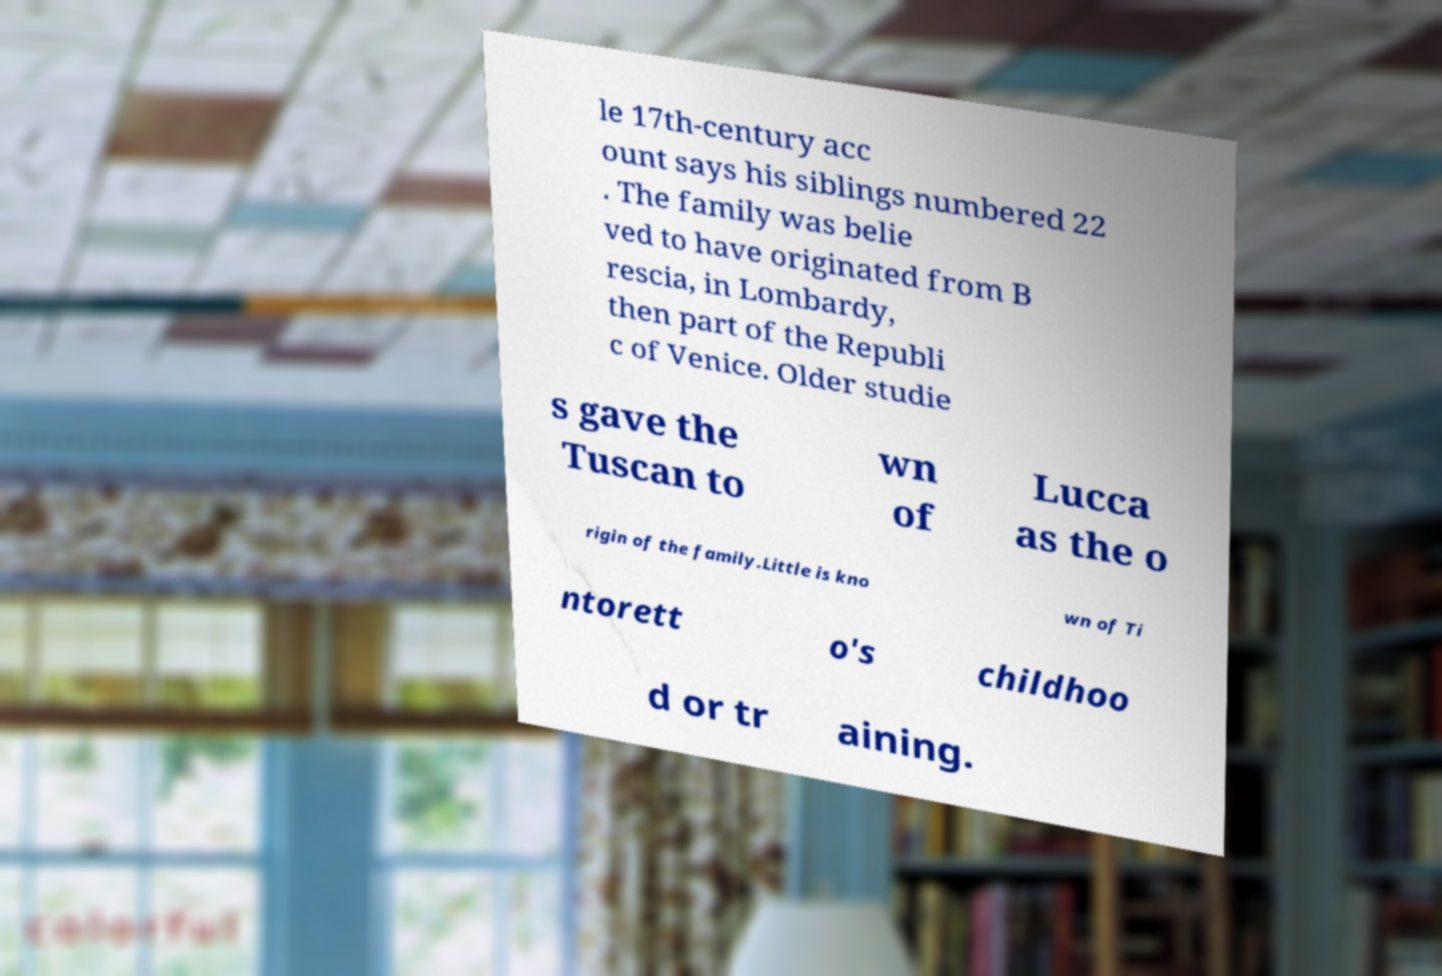Could you assist in decoding the text presented in this image and type it out clearly? le 17th-century acc ount says his siblings numbered 22 . The family was belie ved to have originated from B rescia, in Lombardy, then part of the Republi c of Venice. Older studie s gave the Tuscan to wn of Lucca as the o rigin of the family.Little is kno wn of Ti ntorett o's childhoo d or tr aining. 